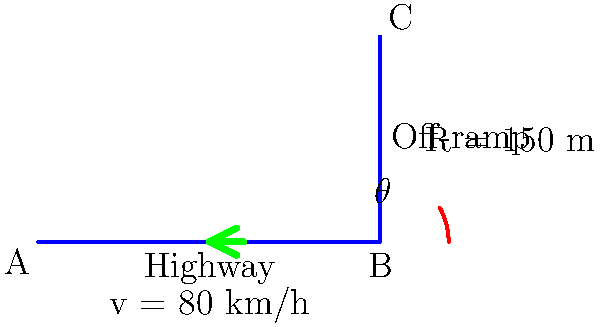As a car enthusiast familiar with vehicle dynamics, you're consulting on the design of a highway off-ramp. Given a vehicle speed of 80 km/h and a curve radius of 150 m, what is the optimal angle $\theta$ (in degrees) for the off-ramp to ensure safe and comfortable deceleration? Assume a standard coefficient of friction of 0.7 between the tires and the road surface. To determine the optimal angle for the highway off-ramp, we'll use the principles of vehicle dynamics and road design. Here's a step-by-step approach:

1. Convert the vehicle speed from km/h to m/s:
   $v = 80 \text{ km/h} = 80 \times \frac{1000}{3600} = 22.22 \text{ m/s}$

2. Use the formula for the maximum safe speed on a curve, considering both friction and banking angle:
   $v = \sqrt{g R (\mu + \tan\theta)}$

   Where:
   $v$ is the vehicle speed (m/s)
   $g$ is the acceleration due to gravity (9.81 m/s²)
   $R$ is the radius of the curve (150 m)
   $\mu$ is the coefficient of friction (0.7)
   $\theta$ is the banking angle (what we're solving for)

3. Rearrange the formula to solve for $\tan\theta$:
   $22.22 = \sqrt{9.81 \times 150 (\mu + \tan\theta)}$
   $493.73 = 1471.5 (\mu + \tan\theta)$
   $0.3355 = \mu + \tan\theta$
   $\tan\theta = 0.3355 - 0.7 = -0.3645$

4. Calculate $\theta$ using the inverse tangent function:
   $\theta = \tan^{-1}(-0.3645) = -20.02°$

5. The negative angle indicates that the road should be banked inward (superelevation). We take the absolute value for the final answer.

The optimal angle for the off-ramp is approximately 20.02°.
Answer: 20.02° 